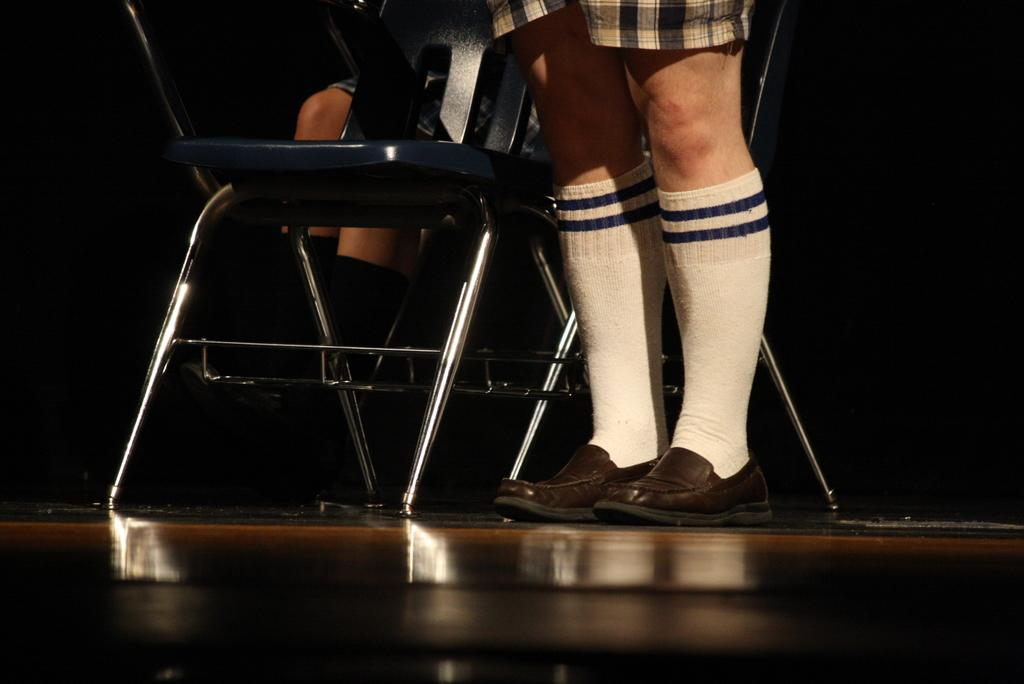What can be seen in the image that belongs to a person? There are legs of a person in the image. What type of furniture is present in the image? There is a chair in the image. Are there any other people visible in the image? Yes, there are legs of another person behind the chair. What type of toothpaste is being used by the person in the image? There is no toothpaste present in the image; it only shows legs of a person and a chair. Can you tell me the color of the berry that the person is holding in the image? There is no berry present in the image. 